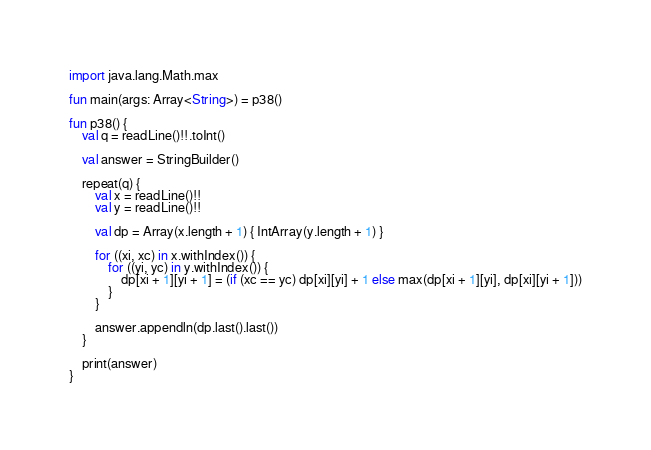<code> <loc_0><loc_0><loc_500><loc_500><_Kotlin_>import java.lang.Math.max

fun main(args: Array<String>) = p38()

fun p38() {
    val q = readLine()!!.toInt()

    val answer = StringBuilder()

    repeat(q) {
        val x = readLine()!!
        val y = readLine()!!

        val dp = Array(x.length + 1) { IntArray(y.length + 1) }

        for ((xi, xc) in x.withIndex()) {
            for ((yi, yc) in y.withIndex()) {
                dp[xi + 1][yi + 1] = (if (xc == yc) dp[xi][yi] + 1 else max(dp[xi + 1][yi], dp[xi][yi + 1]))
            }
        }

        answer.appendln(dp.last().last())
    }

    print(answer)
}

</code> 